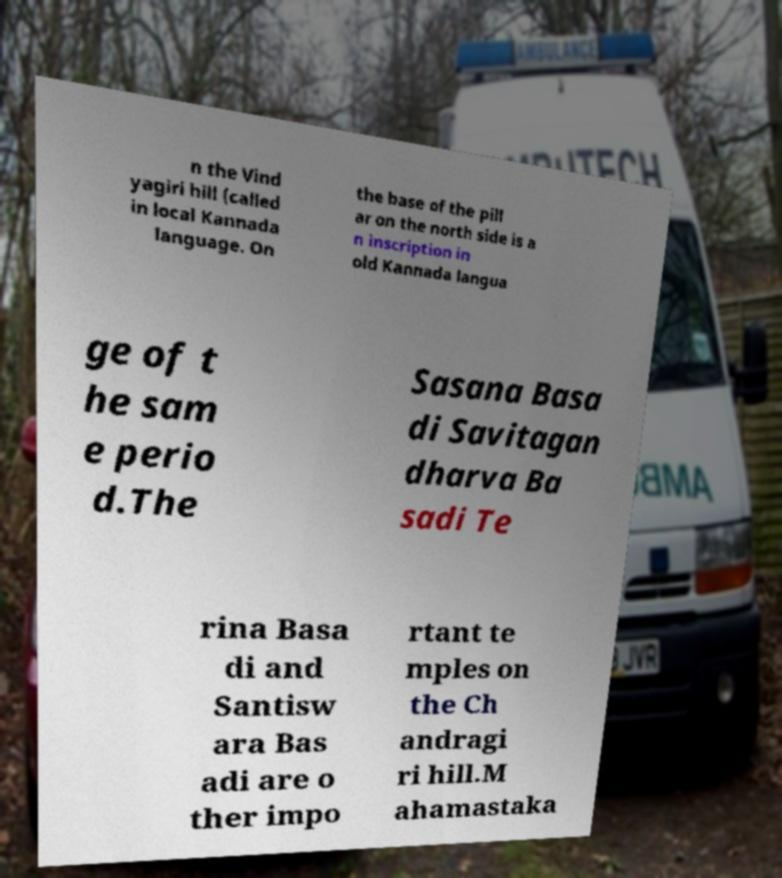For documentation purposes, I need the text within this image transcribed. Could you provide that? n the Vind yagiri hill (called in local Kannada language. On the base of the pill ar on the north side is a n inscription in old Kannada langua ge of t he sam e perio d.The Sasana Basa di Savitagan dharva Ba sadi Te rina Basa di and Santisw ara Bas adi are o ther impo rtant te mples on the Ch andragi ri hill.M ahamastaka 